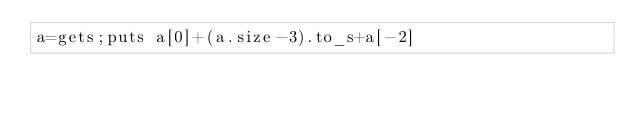<code> <loc_0><loc_0><loc_500><loc_500><_Ruby_>a=gets;puts a[0]+(a.size-3).to_s+a[-2]</code> 